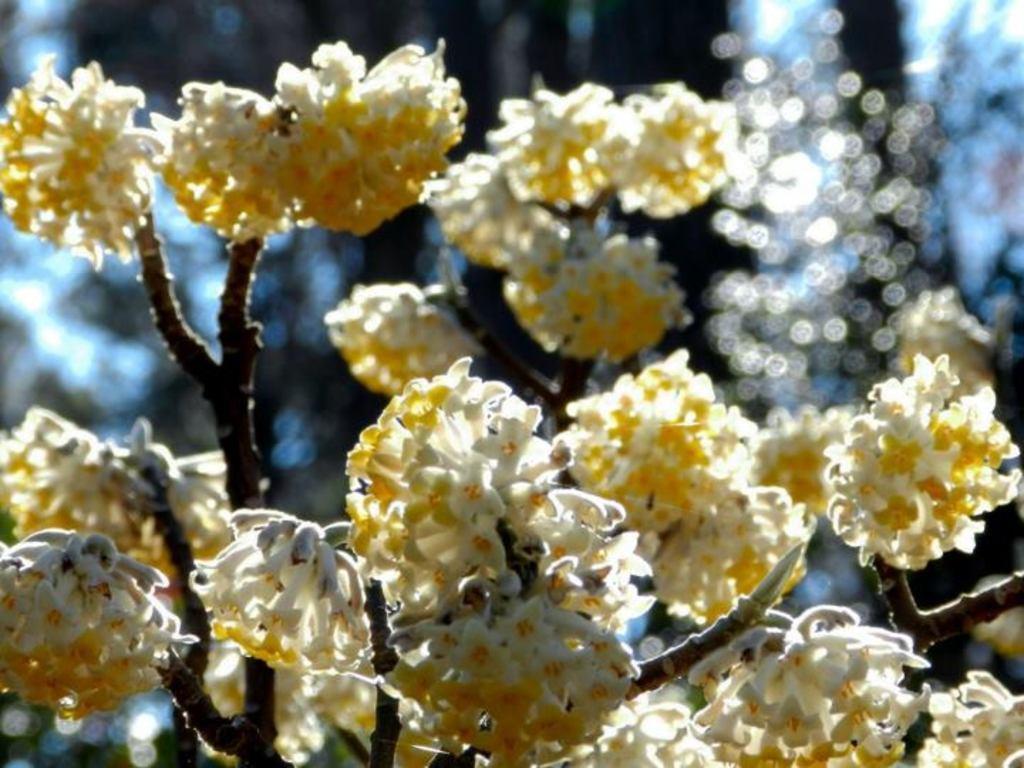Please provide a concise description of this image. In this image there are flowers with branches. 